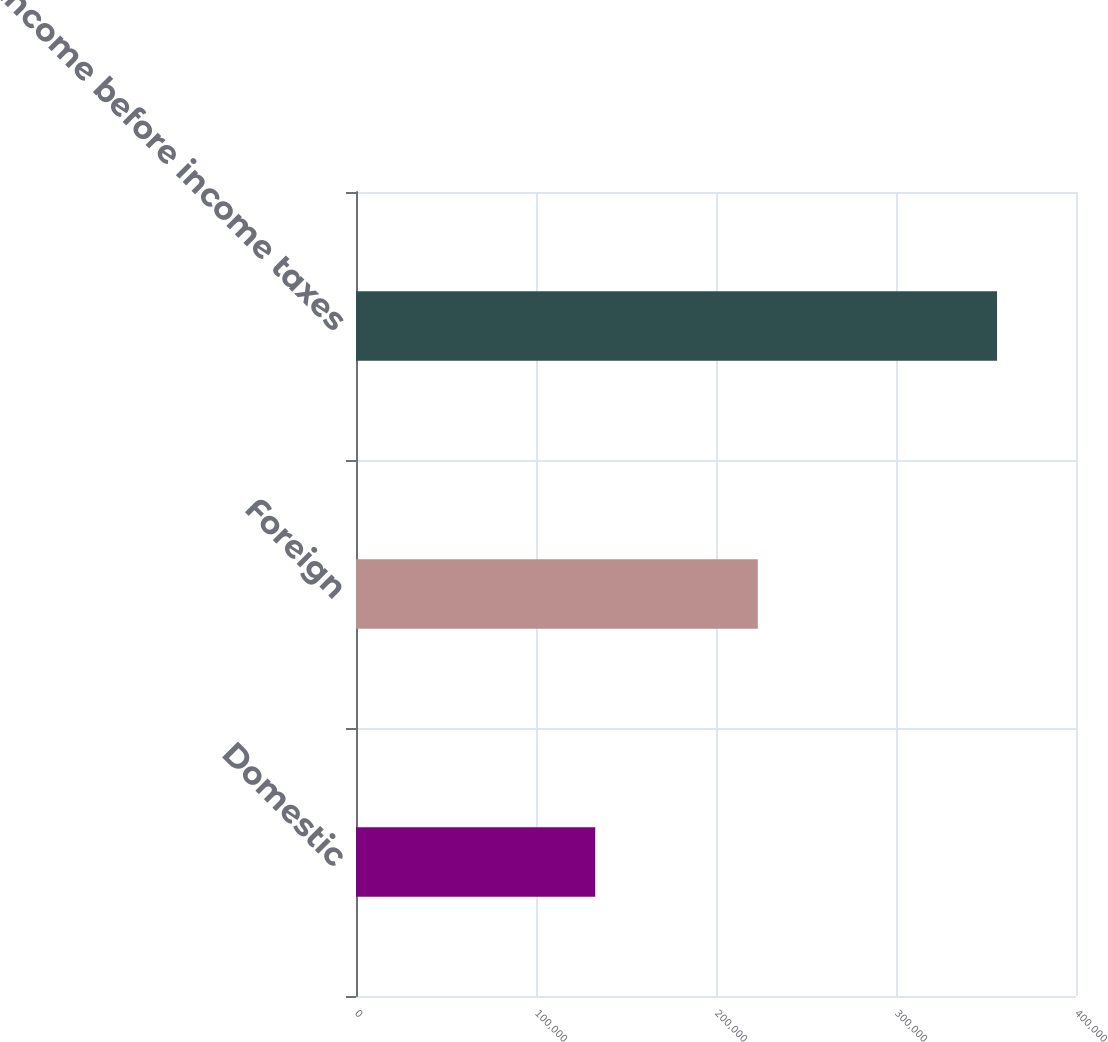Convert chart. <chart><loc_0><loc_0><loc_500><loc_500><bar_chart><fcel>Domestic<fcel>Foreign<fcel>Income before income taxes<nl><fcel>132916<fcel>223225<fcel>356141<nl></chart> 